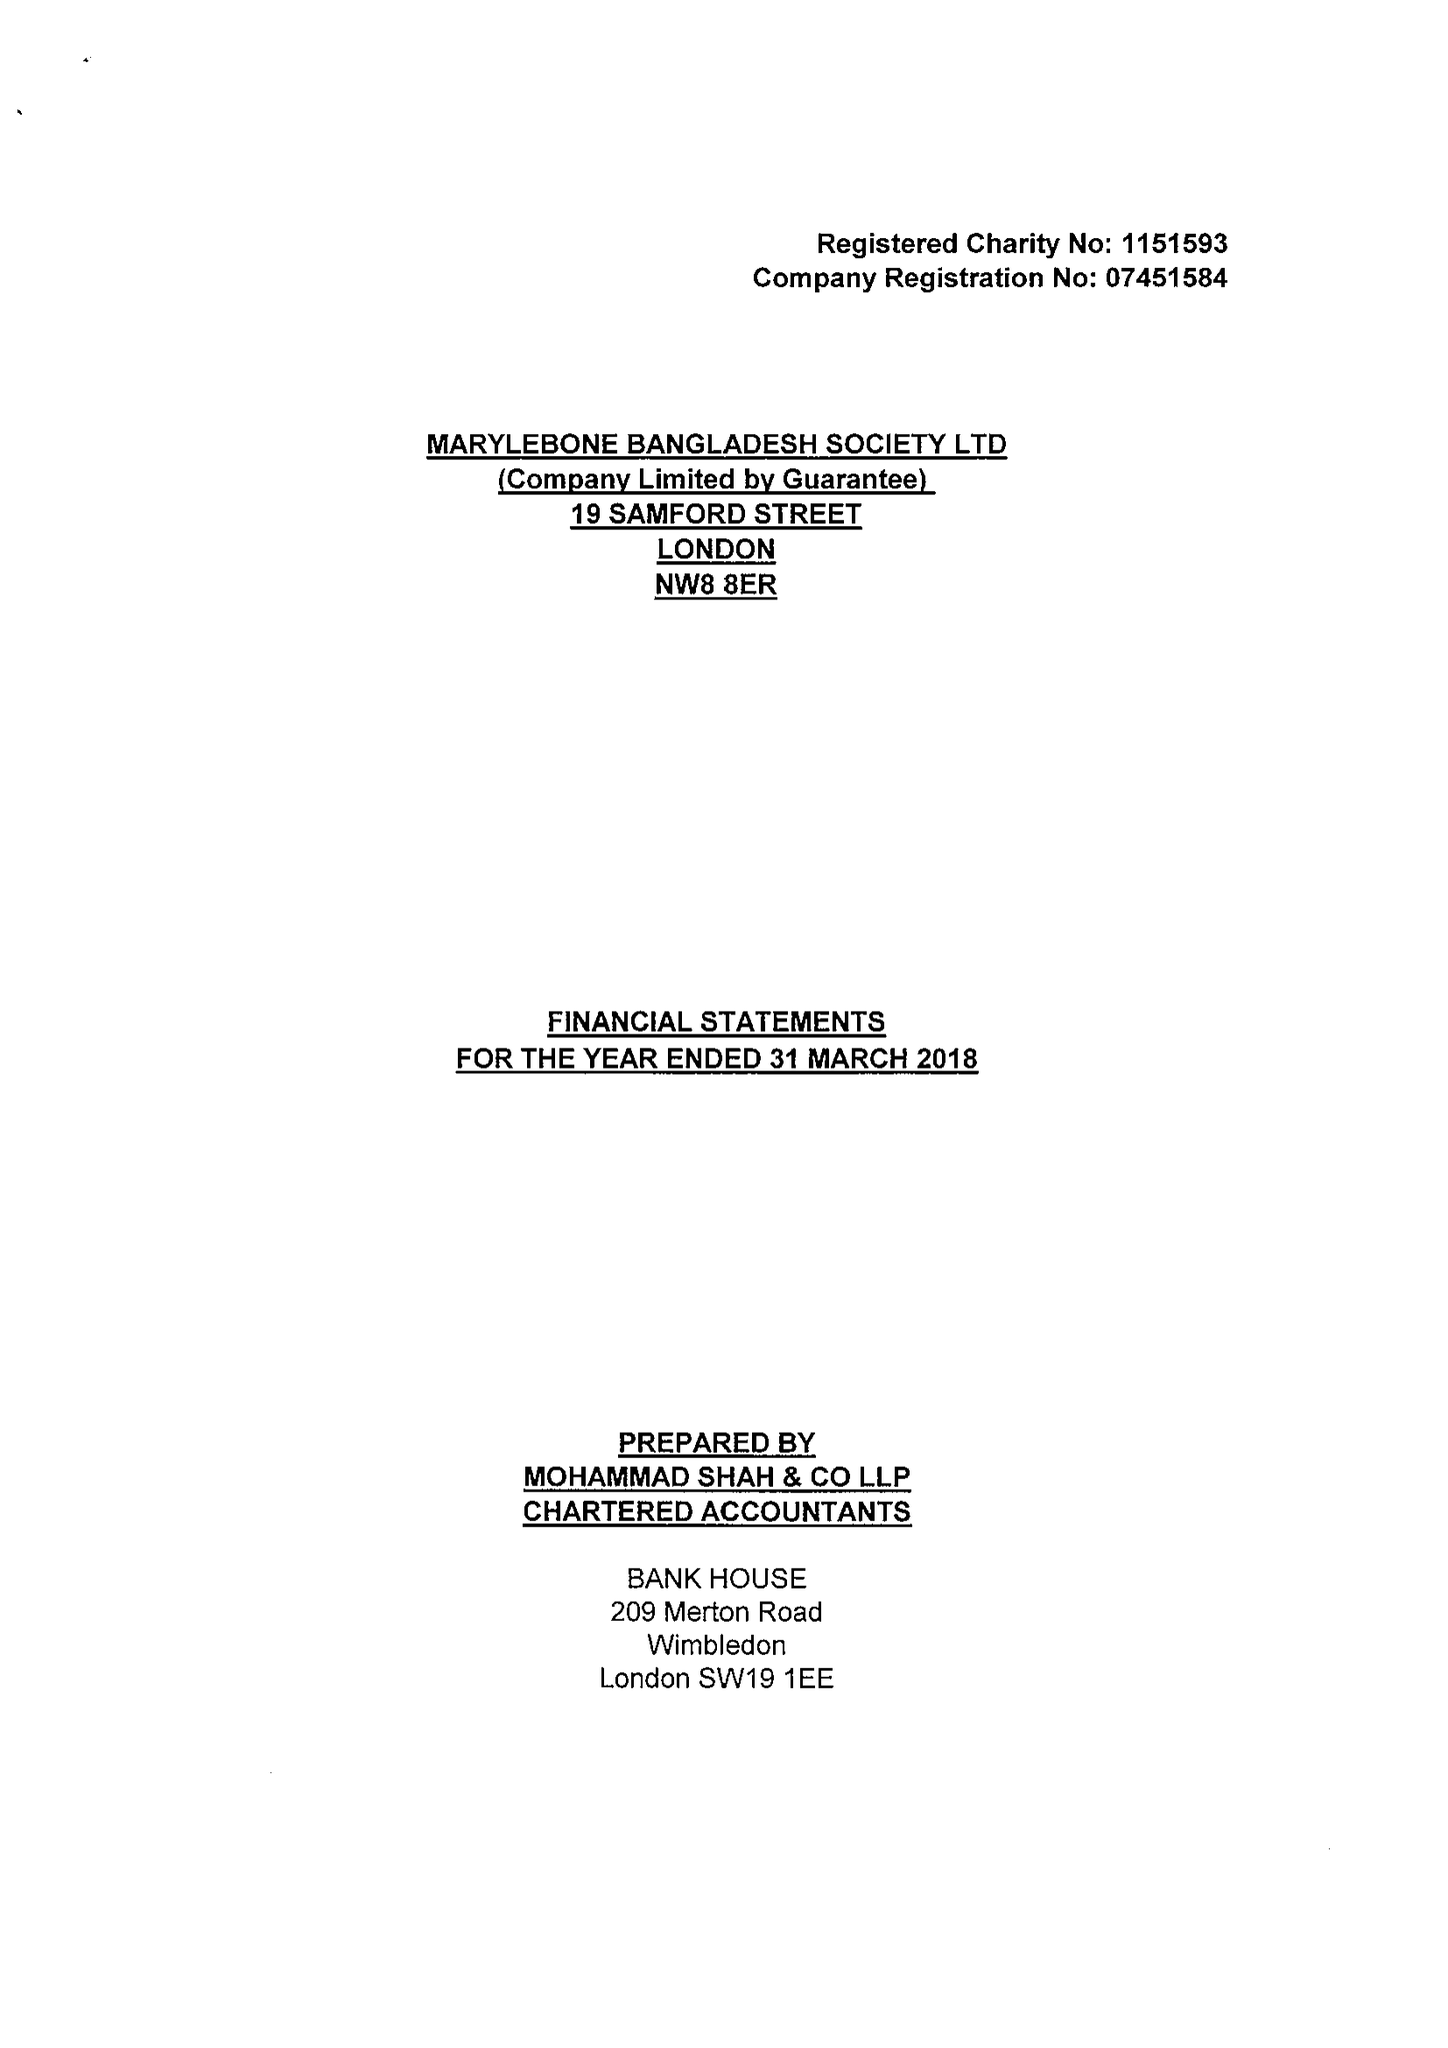What is the value for the income_annually_in_british_pounds?
Answer the question using a single word or phrase. 145444.00 